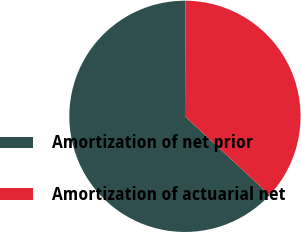Convert chart to OTSL. <chart><loc_0><loc_0><loc_500><loc_500><pie_chart><fcel>Amortization of net prior<fcel>Amortization of actuarial net<nl><fcel>63.16%<fcel>36.84%<nl></chart> 